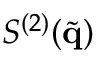Convert formula to latex. <formula><loc_0><loc_0><loc_500><loc_500>S ^ { ( 2 ) } ( \tilde { q } )</formula> 